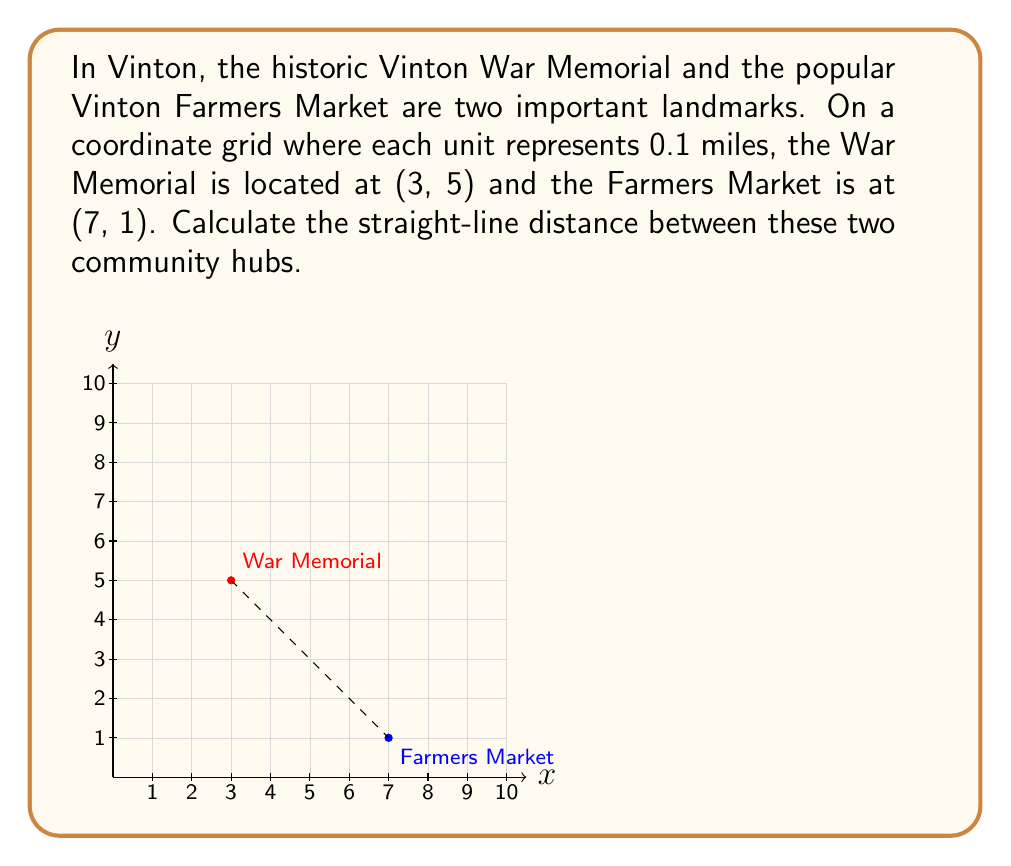Help me with this question. To find the distance between two points on a coordinate grid, we can use the distance formula, which is derived from the Pythagorean theorem:

$$ d = \sqrt{(x_2 - x_1)^2 + (y_2 - y_1)^2} $$

Where $(x_1, y_1)$ is the coordinate of the first point and $(x_2, y_2)$ is the coordinate of the second point.

Let's solve this step-by-step:

1) The War Memorial is at (3, 5) and the Farmers Market is at (7, 1).
   So, $(x_1, y_1) = (3, 5)$ and $(x_2, y_2) = (7, 1)$

2) Plug these values into the distance formula:

   $$ d = \sqrt{(7 - 3)^2 + (1 - 5)^2} $$

3) Simplify inside the parentheses:

   $$ d = \sqrt{4^2 + (-4)^2} $$

4) Calculate the squares:

   $$ d = \sqrt{16 + 16} $$

5) Add under the square root:

   $$ d = \sqrt{32} $$

6) Simplify the square root:

   $$ d = 4\sqrt{2} $$

7) Remember that each unit represents 0.1 miles. So we need to multiply our result by 0.1:

   $$ d = 0.1 \times 4\sqrt{2} = 0.4\sqrt{2} \text{ miles} $$

This is approximately 0.57 miles.
Answer: $0.4\sqrt{2}$ miles (or approximately 0.57 miles) 